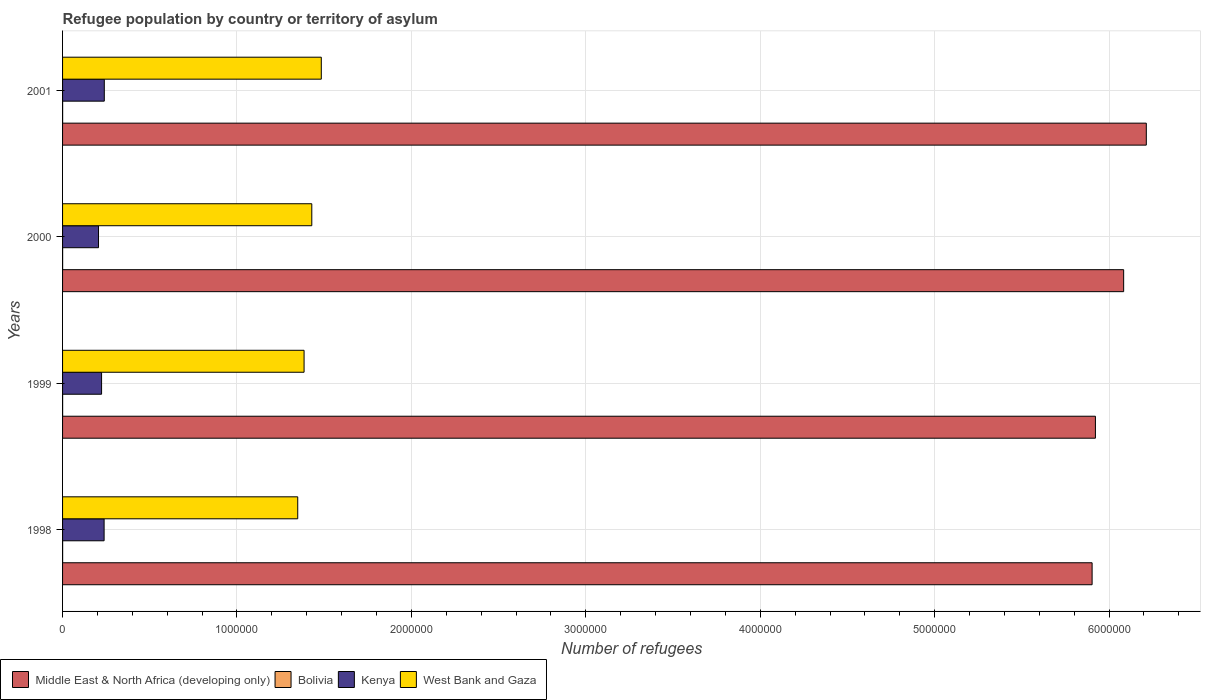How many different coloured bars are there?
Provide a short and direct response. 4. How many groups of bars are there?
Make the answer very short. 4. How many bars are there on the 3rd tick from the top?
Your answer should be compact. 4. What is the label of the 2nd group of bars from the top?
Offer a very short reply. 2000. What is the number of refugees in Bolivia in 1998?
Provide a short and direct response. 349. Across all years, what is the maximum number of refugees in West Bank and Gaza?
Your answer should be very brief. 1.48e+06. Across all years, what is the minimum number of refugees in West Bank and Gaza?
Your answer should be very brief. 1.35e+06. What is the total number of refugees in Bolivia in the graph?
Give a very brief answer. 1397. What is the difference between the number of refugees in Kenya in 1999 and that in 2001?
Give a very brief answer. -1.55e+04. What is the difference between the number of refugees in Bolivia in 2000 and the number of refugees in West Bank and Gaza in 1999?
Offer a very short reply. -1.38e+06. What is the average number of refugees in Kenya per year?
Provide a short and direct response. 2.27e+05. In the year 2001, what is the difference between the number of refugees in Kenya and number of refugees in West Bank and Gaza?
Keep it short and to the point. -1.24e+06. In how many years, is the number of refugees in Middle East & North Africa (developing only) greater than 600000 ?
Offer a terse response. 4. What is the ratio of the number of refugees in Bolivia in 1998 to that in 2001?
Your response must be concise. 1.01. Is the number of refugees in Kenya in 1998 less than that in 2000?
Offer a terse response. No. Is the difference between the number of refugees in Kenya in 2000 and 2001 greater than the difference between the number of refugees in West Bank and Gaza in 2000 and 2001?
Offer a very short reply. Yes. What is the difference between the highest and the second highest number of refugees in Kenya?
Offer a very short reply. 1034. What is the difference between the highest and the lowest number of refugees in Middle East & North Africa (developing only)?
Your answer should be compact. 3.11e+05. Is it the case that in every year, the sum of the number of refugees in Kenya and number of refugees in West Bank and Gaza is greater than the sum of number of refugees in Bolivia and number of refugees in Middle East & North Africa (developing only)?
Provide a short and direct response. No. What does the 3rd bar from the top in 1998 represents?
Offer a terse response. Bolivia. What does the 1st bar from the bottom in 1999 represents?
Provide a short and direct response. Middle East & North Africa (developing only). How many years are there in the graph?
Provide a succinct answer. 4. Does the graph contain any zero values?
Provide a succinct answer. No. Does the graph contain grids?
Your answer should be compact. Yes. Where does the legend appear in the graph?
Keep it short and to the point. Bottom left. How many legend labels are there?
Ensure brevity in your answer.  4. What is the title of the graph?
Your response must be concise. Refugee population by country or territory of asylum. Does "Iraq" appear as one of the legend labels in the graph?
Your response must be concise. No. What is the label or title of the X-axis?
Offer a terse response. Number of refugees. What is the label or title of the Y-axis?
Your answer should be compact. Years. What is the Number of refugees of Middle East & North Africa (developing only) in 1998?
Offer a terse response. 5.90e+06. What is the Number of refugees of Bolivia in 1998?
Ensure brevity in your answer.  349. What is the Number of refugees of Kenya in 1998?
Keep it short and to the point. 2.38e+05. What is the Number of refugees in West Bank and Gaza in 1998?
Give a very brief answer. 1.35e+06. What is the Number of refugees of Middle East & North Africa (developing only) in 1999?
Your answer should be compact. 5.92e+06. What is the Number of refugees of Bolivia in 1999?
Offer a terse response. 350. What is the Number of refugees of Kenya in 1999?
Your response must be concise. 2.24e+05. What is the Number of refugees of West Bank and Gaza in 1999?
Offer a very short reply. 1.38e+06. What is the Number of refugees of Middle East & North Africa (developing only) in 2000?
Provide a short and direct response. 6.08e+06. What is the Number of refugees of Bolivia in 2000?
Your response must be concise. 351. What is the Number of refugees in Kenya in 2000?
Offer a terse response. 2.06e+05. What is the Number of refugees of West Bank and Gaza in 2000?
Offer a very short reply. 1.43e+06. What is the Number of refugees in Middle East & North Africa (developing only) in 2001?
Your answer should be very brief. 6.21e+06. What is the Number of refugees of Bolivia in 2001?
Offer a terse response. 347. What is the Number of refugees in Kenya in 2001?
Provide a short and direct response. 2.39e+05. What is the Number of refugees in West Bank and Gaza in 2001?
Ensure brevity in your answer.  1.48e+06. Across all years, what is the maximum Number of refugees of Middle East & North Africa (developing only)?
Your response must be concise. 6.21e+06. Across all years, what is the maximum Number of refugees of Bolivia?
Give a very brief answer. 351. Across all years, what is the maximum Number of refugees in Kenya?
Give a very brief answer. 2.39e+05. Across all years, what is the maximum Number of refugees in West Bank and Gaza?
Keep it short and to the point. 1.48e+06. Across all years, what is the minimum Number of refugees of Middle East & North Africa (developing only)?
Offer a terse response. 5.90e+06. Across all years, what is the minimum Number of refugees in Bolivia?
Offer a very short reply. 347. Across all years, what is the minimum Number of refugees in Kenya?
Your response must be concise. 2.06e+05. Across all years, what is the minimum Number of refugees in West Bank and Gaza?
Ensure brevity in your answer.  1.35e+06. What is the total Number of refugees in Middle East & North Africa (developing only) in the graph?
Keep it short and to the point. 2.41e+07. What is the total Number of refugees of Bolivia in the graph?
Offer a very short reply. 1397. What is the total Number of refugees of Kenya in the graph?
Ensure brevity in your answer.  9.07e+05. What is the total Number of refugees in West Bank and Gaza in the graph?
Your answer should be very brief. 5.65e+06. What is the difference between the Number of refugees of Middle East & North Africa (developing only) in 1998 and that in 1999?
Offer a terse response. -1.90e+04. What is the difference between the Number of refugees in Bolivia in 1998 and that in 1999?
Ensure brevity in your answer.  -1. What is the difference between the Number of refugees of Kenya in 1998 and that in 1999?
Provide a short and direct response. 1.45e+04. What is the difference between the Number of refugees in West Bank and Gaza in 1998 and that in 1999?
Your answer should be compact. -3.64e+04. What is the difference between the Number of refugees in Middle East & North Africa (developing only) in 1998 and that in 2000?
Provide a short and direct response. -1.81e+05. What is the difference between the Number of refugees of Kenya in 1998 and that in 2000?
Your response must be concise. 3.21e+04. What is the difference between the Number of refugees of West Bank and Gaza in 1998 and that in 2000?
Make the answer very short. -8.06e+04. What is the difference between the Number of refugees in Middle East & North Africa (developing only) in 1998 and that in 2001?
Offer a very short reply. -3.11e+05. What is the difference between the Number of refugees in Kenya in 1998 and that in 2001?
Provide a short and direct response. -1034. What is the difference between the Number of refugees of West Bank and Gaza in 1998 and that in 2001?
Give a very brief answer. -1.35e+05. What is the difference between the Number of refugees of Middle East & North Africa (developing only) in 1999 and that in 2000?
Your answer should be very brief. -1.62e+05. What is the difference between the Number of refugees in Bolivia in 1999 and that in 2000?
Keep it short and to the point. -1. What is the difference between the Number of refugees in Kenya in 1999 and that in 2000?
Your response must be concise. 1.76e+04. What is the difference between the Number of refugees of West Bank and Gaza in 1999 and that in 2000?
Ensure brevity in your answer.  -4.42e+04. What is the difference between the Number of refugees of Middle East & North Africa (developing only) in 1999 and that in 2001?
Provide a short and direct response. -2.92e+05. What is the difference between the Number of refugees in Kenya in 1999 and that in 2001?
Ensure brevity in your answer.  -1.55e+04. What is the difference between the Number of refugees of West Bank and Gaza in 1999 and that in 2001?
Give a very brief answer. -9.87e+04. What is the difference between the Number of refugees in Middle East & North Africa (developing only) in 2000 and that in 2001?
Your response must be concise. -1.30e+05. What is the difference between the Number of refugees of Bolivia in 2000 and that in 2001?
Your response must be concise. 4. What is the difference between the Number of refugees in Kenya in 2000 and that in 2001?
Offer a very short reply. -3.31e+04. What is the difference between the Number of refugees in West Bank and Gaza in 2000 and that in 2001?
Your answer should be compact. -5.45e+04. What is the difference between the Number of refugees of Middle East & North Africa (developing only) in 1998 and the Number of refugees of Bolivia in 1999?
Ensure brevity in your answer.  5.90e+06. What is the difference between the Number of refugees of Middle East & North Africa (developing only) in 1998 and the Number of refugees of Kenya in 1999?
Your response must be concise. 5.68e+06. What is the difference between the Number of refugees of Middle East & North Africa (developing only) in 1998 and the Number of refugees of West Bank and Gaza in 1999?
Ensure brevity in your answer.  4.52e+06. What is the difference between the Number of refugees in Bolivia in 1998 and the Number of refugees in Kenya in 1999?
Your answer should be very brief. -2.23e+05. What is the difference between the Number of refugees in Bolivia in 1998 and the Number of refugees in West Bank and Gaza in 1999?
Offer a very short reply. -1.38e+06. What is the difference between the Number of refugees of Kenya in 1998 and the Number of refugees of West Bank and Gaza in 1999?
Keep it short and to the point. -1.15e+06. What is the difference between the Number of refugees of Middle East & North Africa (developing only) in 1998 and the Number of refugees of Bolivia in 2000?
Offer a terse response. 5.90e+06. What is the difference between the Number of refugees of Middle East & North Africa (developing only) in 1998 and the Number of refugees of Kenya in 2000?
Ensure brevity in your answer.  5.70e+06. What is the difference between the Number of refugees of Middle East & North Africa (developing only) in 1998 and the Number of refugees of West Bank and Gaza in 2000?
Offer a very short reply. 4.47e+06. What is the difference between the Number of refugees of Bolivia in 1998 and the Number of refugees of Kenya in 2000?
Ensure brevity in your answer.  -2.06e+05. What is the difference between the Number of refugees in Bolivia in 1998 and the Number of refugees in West Bank and Gaza in 2000?
Your answer should be very brief. -1.43e+06. What is the difference between the Number of refugees in Kenya in 1998 and the Number of refugees in West Bank and Gaza in 2000?
Offer a terse response. -1.19e+06. What is the difference between the Number of refugees in Middle East & North Africa (developing only) in 1998 and the Number of refugees in Bolivia in 2001?
Give a very brief answer. 5.90e+06. What is the difference between the Number of refugees in Middle East & North Africa (developing only) in 1998 and the Number of refugees in Kenya in 2001?
Provide a short and direct response. 5.66e+06. What is the difference between the Number of refugees in Middle East & North Africa (developing only) in 1998 and the Number of refugees in West Bank and Gaza in 2001?
Provide a succinct answer. 4.42e+06. What is the difference between the Number of refugees in Bolivia in 1998 and the Number of refugees in Kenya in 2001?
Offer a terse response. -2.39e+05. What is the difference between the Number of refugees in Bolivia in 1998 and the Number of refugees in West Bank and Gaza in 2001?
Offer a terse response. -1.48e+06. What is the difference between the Number of refugees in Kenya in 1998 and the Number of refugees in West Bank and Gaza in 2001?
Give a very brief answer. -1.25e+06. What is the difference between the Number of refugees in Middle East & North Africa (developing only) in 1999 and the Number of refugees in Bolivia in 2000?
Provide a short and direct response. 5.92e+06. What is the difference between the Number of refugees in Middle East & North Africa (developing only) in 1999 and the Number of refugees in Kenya in 2000?
Keep it short and to the point. 5.72e+06. What is the difference between the Number of refugees in Middle East & North Africa (developing only) in 1999 and the Number of refugees in West Bank and Gaza in 2000?
Your response must be concise. 4.49e+06. What is the difference between the Number of refugees of Bolivia in 1999 and the Number of refugees of Kenya in 2000?
Make the answer very short. -2.06e+05. What is the difference between the Number of refugees of Bolivia in 1999 and the Number of refugees of West Bank and Gaza in 2000?
Ensure brevity in your answer.  -1.43e+06. What is the difference between the Number of refugees in Kenya in 1999 and the Number of refugees in West Bank and Gaza in 2000?
Ensure brevity in your answer.  -1.21e+06. What is the difference between the Number of refugees in Middle East & North Africa (developing only) in 1999 and the Number of refugees in Bolivia in 2001?
Provide a succinct answer. 5.92e+06. What is the difference between the Number of refugees of Middle East & North Africa (developing only) in 1999 and the Number of refugees of Kenya in 2001?
Your response must be concise. 5.68e+06. What is the difference between the Number of refugees in Middle East & North Africa (developing only) in 1999 and the Number of refugees in West Bank and Gaza in 2001?
Your answer should be very brief. 4.44e+06. What is the difference between the Number of refugees in Bolivia in 1999 and the Number of refugees in Kenya in 2001?
Offer a terse response. -2.39e+05. What is the difference between the Number of refugees in Bolivia in 1999 and the Number of refugees in West Bank and Gaza in 2001?
Provide a short and direct response. -1.48e+06. What is the difference between the Number of refugees in Kenya in 1999 and the Number of refugees in West Bank and Gaza in 2001?
Make the answer very short. -1.26e+06. What is the difference between the Number of refugees of Middle East & North Africa (developing only) in 2000 and the Number of refugees of Bolivia in 2001?
Keep it short and to the point. 6.08e+06. What is the difference between the Number of refugees in Middle East & North Africa (developing only) in 2000 and the Number of refugees in Kenya in 2001?
Keep it short and to the point. 5.84e+06. What is the difference between the Number of refugees in Middle East & North Africa (developing only) in 2000 and the Number of refugees in West Bank and Gaza in 2001?
Ensure brevity in your answer.  4.60e+06. What is the difference between the Number of refugees in Bolivia in 2000 and the Number of refugees in Kenya in 2001?
Your response must be concise. -2.39e+05. What is the difference between the Number of refugees in Bolivia in 2000 and the Number of refugees in West Bank and Gaza in 2001?
Offer a terse response. -1.48e+06. What is the difference between the Number of refugees of Kenya in 2000 and the Number of refugees of West Bank and Gaza in 2001?
Give a very brief answer. -1.28e+06. What is the average Number of refugees of Middle East & North Africa (developing only) per year?
Your response must be concise. 6.03e+06. What is the average Number of refugees of Bolivia per year?
Make the answer very short. 349.25. What is the average Number of refugees of Kenya per year?
Provide a short and direct response. 2.27e+05. What is the average Number of refugees in West Bank and Gaza per year?
Provide a short and direct response. 1.41e+06. In the year 1998, what is the difference between the Number of refugees of Middle East & North Africa (developing only) and Number of refugees of Bolivia?
Provide a succinct answer. 5.90e+06. In the year 1998, what is the difference between the Number of refugees of Middle East & North Africa (developing only) and Number of refugees of Kenya?
Give a very brief answer. 5.66e+06. In the year 1998, what is the difference between the Number of refugees in Middle East & North Africa (developing only) and Number of refugees in West Bank and Gaza?
Provide a succinct answer. 4.55e+06. In the year 1998, what is the difference between the Number of refugees in Bolivia and Number of refugees in Kenya?
Your response must be concise. -2.38e+05. In the year 1998, what is the difference between the Number of refugees of Bolivia and Number of refugees of West Bank and Gaza?
Offer a terse response. -1.35e+06. In the year 1998, what is the difference between the Number of refugees of Kenya and Number of refugees of West Bank and Gaza?
Ensure brevity in your answer.  -1.11e+06. In the year 1999, what is the difference between the Number of refugees in Middle East & North Africa (developing only) and Number of refugees in Bolivia?
Offer a very short reply. 5.92e+06. In the year 1999, what is the difference between the Number of refugees of Middle East & North Africa (developing only) and Number of refugees of Kenya?
Your answer should be very brief. 5.70e+06. In the year 1999, what is the difference between the Number of refugees in Middle East & North Africa (developing only) and Number of refugees in West Bank and Gaza?
Your response must be concise. 4.54e+06. In the year 1999, what is the difference between the Number of refugees of Bolivia and Number of refugees of Kenya?
Give a very brief answer. -2.23e+05. In the year 1999, what is the difference between the Number of refugees in Bolivia and Number of refugees in West Bank and Gaza?
Give a very brief answer. -1.38e+06. In the year 1999, what is the difference between the Number of refugees in Kenya and Number of refugees in West Bank and Gaza?
Provide a succinct answer. -1.16e+06. In the year 2000, what is the difference between the Number of refugees of Middle East & North Africa (developing only) and Number of refugees of Bolivia?
Your answer should be very brief. 6.08e+06. In the year 2000, what is the difference between the Number of refugees of Middle East & North Africa (developing only) and Number of refugees of Kenya?
Provide a succinct answer. 5.88e+06. In the year 2000, what is the difference between the Number of refugees in Middle East & North Africa (developing only) and Number of refugees in West Bank and Gaza?
Your response must be concise. 4.65e+06. In the year 2000, what is the difference between the Number of refugees in Bolivia and Number of refugees in Kenya?
Provide a succinct answer. -2.06e+05. In the year 2000, what is the difference between the Number of refugees in Bolivia and Number of refugees in West Bank and Gaza?
Make the answer very short. -1.43e+06. In the year 2000, what is the difference between the Number of refugees of Kenya and Number of refugees of West Bank and Gaza?
Offer a very short reply. -1.22e+06. In the year 2001, what is the difference between the Number of refugees of Middle East & North Africa (developing only) and Number of refugees of Bolivia?
Give a very brief answer. 6.21e+06. In the year 2001, what is the difference between the Number of refugees in Middle East & North Africa (developing only) and Number of refugees in Kenya?
Keep it short and to the point. 5.97e+06. In the year 2001, what is the difference between the Number of refugees in Middle East & North Africa (developing only) and Number of refugees in West Bank and Gaza?
Your answer should be compact. 4.73e+06. In the year 2001, what is the difference between the Number of refugees of Bolivia and Number of refugees of Kenya?
Your answer should be very brief. -2.39e+05. In the year 2001, what is the difference between the Number of refugees in Bolivia and Number of refugees in West Bank and Gaza?
Provide a succinct answer. -1.48e+06. In the year 2001, what is the difference between the Number of refugees of Kenya and Number of refugees of West Bank and Gaza?
Ensure brevity in your answer.  -1.24e+06. What is the ratio of the Number of refugees of Middle East & North Africa (developing only) in 1998 to that in 1999?
Your answer should be very brief. 1. What is the ratio of the Number of refugees of Kenya in 1998 to that in 1999?
Your answer should be very brief. 1.06. What is the ratio of the Number of refugees of West Bank and Gaza in 1998 to that in 1999?
Your answer should be very brief. 0.97. What is the ratio of the Number of refugees of Middle East & North Africa (developing only) in 1998 to that in 2000?
Make the answer very short. 0.97. What is the ratio of the Number of refugees of Bolivia in 1998 to that in 2000?
Keep it short and to the point. 0.99. What is the ratio of the Number of refugees of Kenya in 1998 to that in 2000?
Offer a terse response. 1.16. What is the ratio of the Number of refugees in West Bank and Gaza in 1998 to that in 2000?
Your answer should be compact. 0.94. What is the ratio of the Number of refugees in Middle East & North Africa (developing only) in 1998 to that in 2001?
Keep it short and to the point. 0.95. What is the ratio of the Number of refugees in Bolivia in 1998 to that in 2001?
Provide a short and direct response. 1.01. What is the ratio of the Number of refugees in Kenya in 1998 to that in 2001?
Offer a terse response. 1. What is the ratio of the Number of refugees of West Bank and Gaza in 1998 to that in 2001?
Make the answer very short. 0.91. What is the ratio of the Number of refugees in Middle East & North Africa (developing only) in 1999 to that in 2000?
Provide a short and direct response. 0.97. What is the ratio of the Number of refugees of Kenya in 1999 to that in 2000?
Make the answer very short. 1.09. What is the ratio of the Number of refugees of Middle East & North Africa (developing only) in 1999 to that in 2001?
Give a very brief answer. 0.95. What is the ratio of the Number of refugees in Bolivia in 1999 to that in 2001?
Your answer should be compact. 1.01. What is the ratio of the Number of refugees in Kenya in 1999 to that in 2001?
Your answer should be compact. 0.94. What is the ratio of the Number of refugees in West Bank and Gaza in 1999 to that in 2001?
Offer a very short reply. 0.93. What is the ratio of the Number of refugees of Middle East & North Africa (developing only) in 2000 to that in 2001?
Your answer should be very brief. 0.98. What is the ratio of the Number of refugees of Bolivia in 2000 to that in 2001?
Give a very brief answer. 1.01. What is the ratio of the Number of refugees in Kenya in 2000 to that in 2001?
Keep it short and to the point. 0.86. What is the ratio of the Number of refugees in West Bank and Gaza in 2000 to that in 2001?
Offer a very short reply. 0.96. What is the difference between the highest and the second highest Number of refugees of Middle East & North Africa (developing only)?
Ensure brevity in your answer.  1.30e+05. What is the difference between the highest and the second highest Number of refugees in Bolivia?
Make the answer very short. 1. What is the difference between the highest and the second highest Number of refugees in Kenya?
Provide a succinct answer. 1034. What is the difference between the highest and the second highest Number of refugees of West Bank and Gaza?
Offer a terse response. 5.45e+04. What is the difference between the highest and the lowest Number of refugees of Middle East & North Africa (developing only)?
Provide a succinct answer. 3.11e+05. What is the difference between the highest and the lowest Number of refugees in Bolivia?
Your response must be concise. 4. What is the difference between the highest and the lowest Number of refugees of Kenya?
Provide a short and direct response. 3.31e+04. What is the difference between the highest and the lowest Number of refugees of West Bank and Gaza?
Keep it short and to the point. 1.35e+05. 